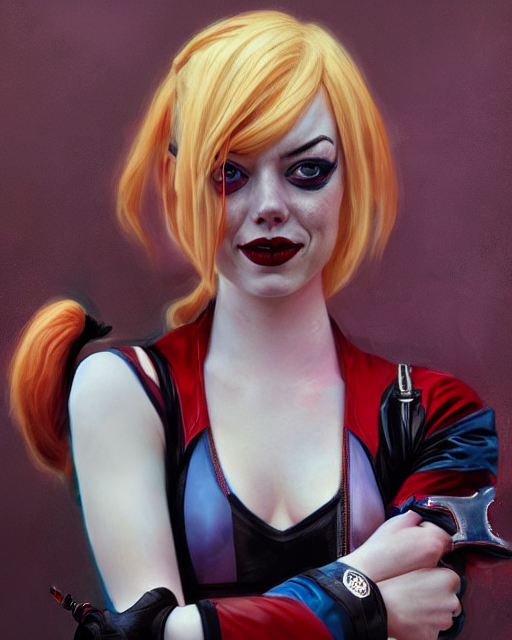What kind of atmosphere does the image evoke? The image evokes a vibrant and somewhat playful atmosphere with a touch of mystery. The subject's colorful appearance, featuring vivid, contrasting reds and blues, stands out against the muted background, suggesting a character who is bold and confident. The creative makeup and expressive look give the impression of someone who might be a performer or participating in a stylized event like comic book cosplay. 